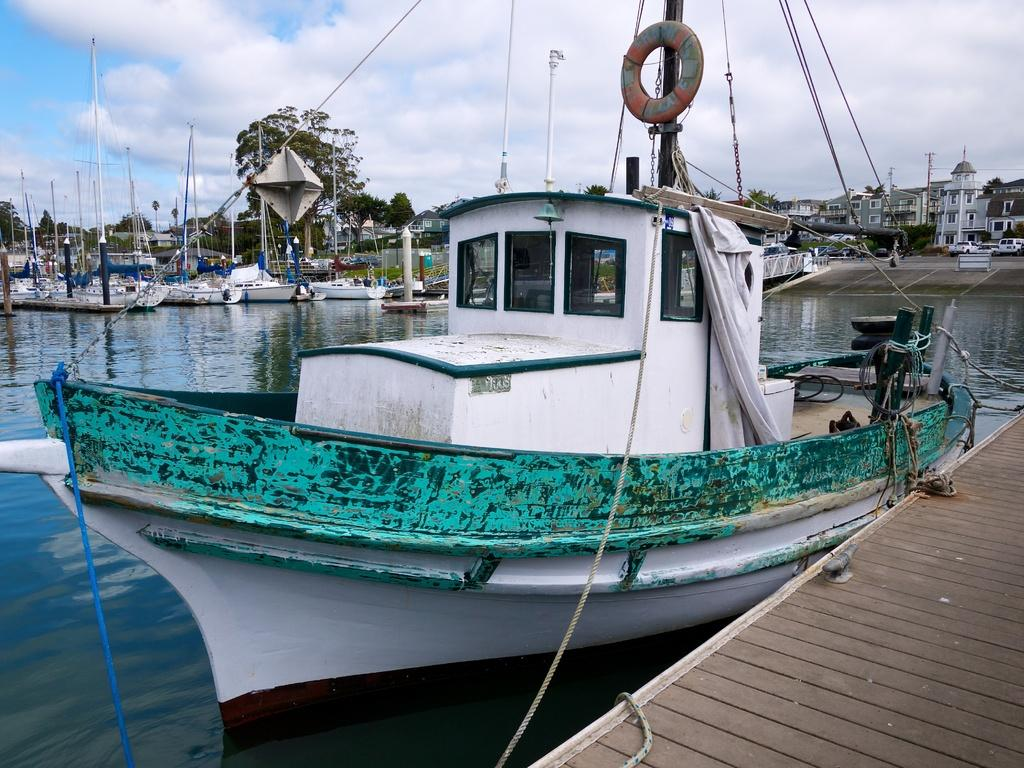What is on the water in the image? There are boats on the water in the image. What is on the road in the image? There are vehicles on the road in the image. What type of structures can be seen in the image? There are buildings with windows in the image. What type of vegetation is present in the image? There are trees in the image. What can be seen in the background of the image? The sky with clouds is visible in the background of the image. How many fingers can be seen holding a conversation in the image? There are no fingers or conversations present in the image. What type of breath is visible coming from the trees in the image? There is no breath visible in the image, as trees do not breathe like humans or animals. 